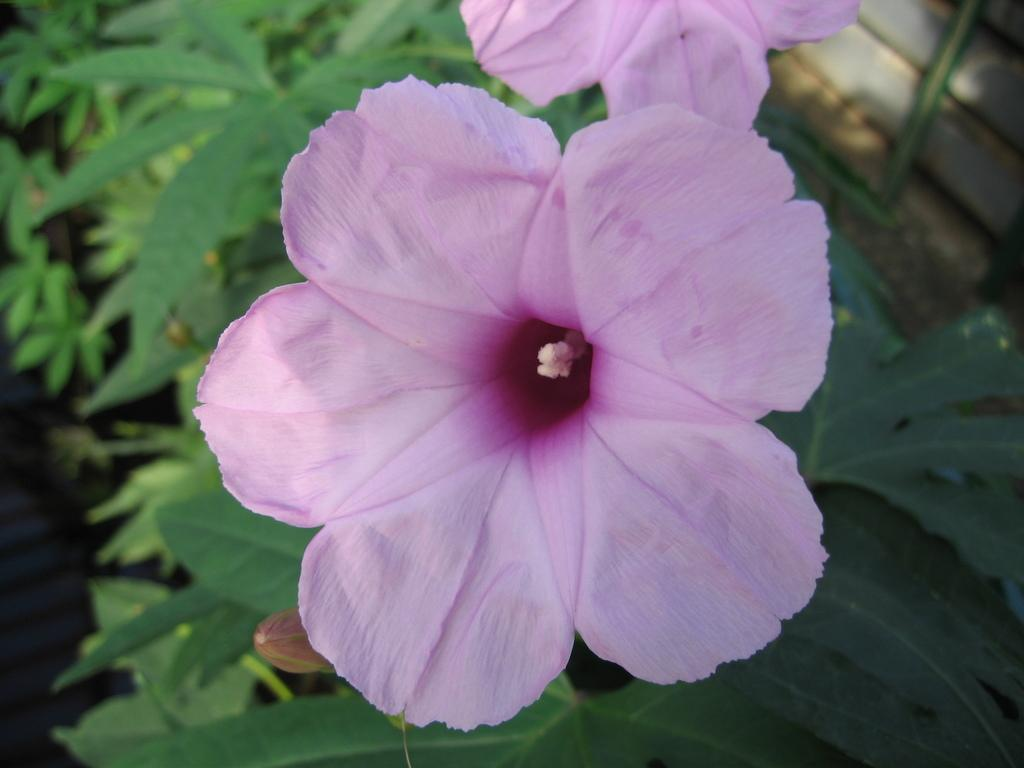What type of living organisms can be seen in the image? There are flowers and plants visible in the image. Can you describe the plants in the image? The plants in the image are not specified, but they are present alongside the flowers. What type of bag is hanging on the bed in the image? There is no bag or bed present in the image; it only features flowers and plants. 